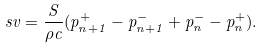<formula> <loc_0><loc_0><loc_500><loc_500>s v = \frac { S } { \rho c } ( p _ { n + 1 } ^ { + } - p _ { n + 1 } ^ { - } + p _ { n } ^ { - } - p _ { n } ^ { + } ) .</formula> 